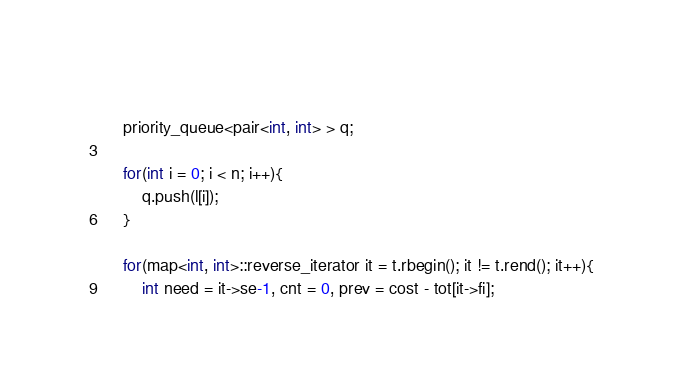<code> <loc_0><loc_0><loc_500><loc_500><_C++_>	
	priority_queue<pair<int, int> > q;
		
	for(int i = 0; i < n; i++){
		q.push(l[i]);
	}
	
	for(map<int, int>::reverse_iterator it = t.rbegin(); it != t.rend(); it++){
		int need = it->se-1, cnt = 0, prev = cost - tot[it->fi];</code> 